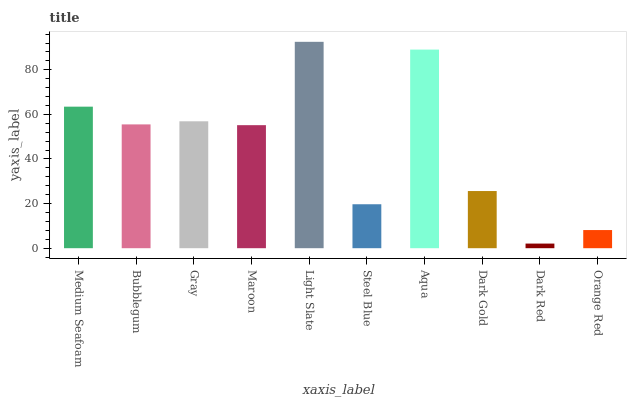Is Bubblegum the minimum?
Answer yes or no. No. Is Bubblegum the maximum?
Answer yes or no. No. Is Medium Seafoam greater than Bubblegum?
Answer yes or no. Yes. Is Bubblegum less than Medium Seafoam?
Answer yes or no. Yes. Is Bubblegum greater than Medium Seafoam?
Answer yes or no. No. Is Medium Seafoam less than Bubblegum?
Answer yes or no. No. Is Bubblegum the high median?
Answer yes or no. Yes. Is Maroon the low median?
Answer yes or no. Yes. Is Medium Seafoam the high median?
Answer yes or no. No. Is Light Slate the low median?
Answer yes or no. No. 